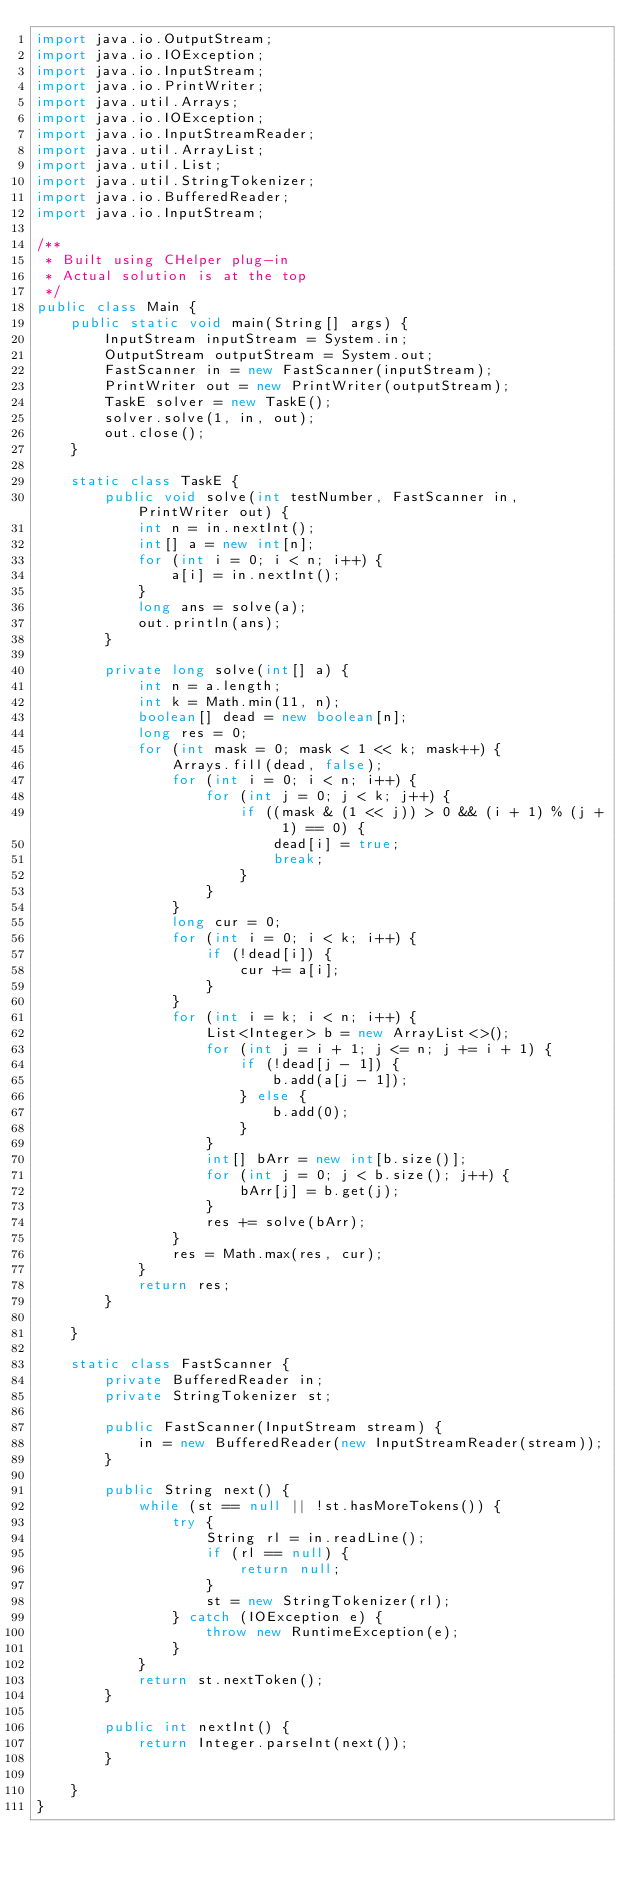Convert code to text. <code><loc_0><loc_0><loc_500><loc_500><_Java_>import java.io.OutputStream;
import java.io.IOException;
import java.io.InputStream;
import java.io.PrintWriter;
import java.util.Arrays;
import java.io.IOException;
import java.io.InputStreamReader;
import java.util.ArrayList;
import java.util.List;
import java.util.StringTokenizer;
import java.io.BufferedReader;
import java.io.InputStream;

/**
 * Built using CHelper plug-in
 * Actual solution is at the top
 */
public class Main {
	public static void main(String[] args) {
		InputStream inputStream = System.in;
		OutputStream outputStream = System.out;
		FastScanner in = new FastScanner(inputStream);
		PrintWriter out = new PrintWriter(outputStream);
		TaskE solver = new TaskE();
		solver.solve(1, in, out);
		out.close();
	}

	static class TaskE {
		public void solve(int testNumber, FastScanner in, PrintWriter out) {
			int n = in.nextInt();
			int[] a = new int[n];
			for (int i = 0; i < n; i++) {
				a[i] = in.nextInt();
			}
			long ans = solve(a);
			out.println(ans);
		}

		private long solve(int[] a) {
			int n = a.length;
			int k = Math.min(11, n);
			boolean[] dead = new boolean[n];
			long res = 0;
			for (int mask = 0; mask < 1 << k; mask++) {
				Arrays.fill(dead, false);
				for (int i = 0; i < n; i++) {
					for (int j = 0; j < k; j++) {
						if ((mask & (1 << j)) > 0 && (i + 1) % (j + 1) == 0) {
							dead[i] = true;
							break;
						}
					}
				}
				long cur = 0;
				for (int i = 0; i < k; i++) {
					if (!dead[i]) {
						cur += a[i];
					}
				}
				for (int i = k; i < n; i++) {
					List<Integer> b = new ArrayList<>();
					for (int j = i + 1; j <= n; j += i + 1) {
						if (!dead[j - 1]) {
							b.add(a[j - 1]);
						} else {
							b.add(0);
						}
					}
					int[] bArr = new int[b.size()];
					for (int j = 0; j < b.size(); j++) {
						bArr[j] = b.get(j);
					}
					res += solve(bArr);
				}
				res = Math.max(res, cur);
			}
			return res;
		}

	}

	static class FastScanner {
		private BufferedReader in;
		private StringTokenizer st;

		public FastScanner(InputStream stream) {
			in = new BufferedReader(new InputStreamReader(stream));
		}

		public String next() {
			while (st == null || !st.hasMoreTokens()) {
				try {
					String rl = in.readLine();
					if (rl == null) {
						return null;
					}
					st = new StringTokenizer(rl);
				} catch (IOException e) {
					throw new RuntimeException(e);
				}
			}
			return st.nextToken();
		}

		public int nextInt() {
			return Integer.parseInt(next());
		}

	}
}

</code> 